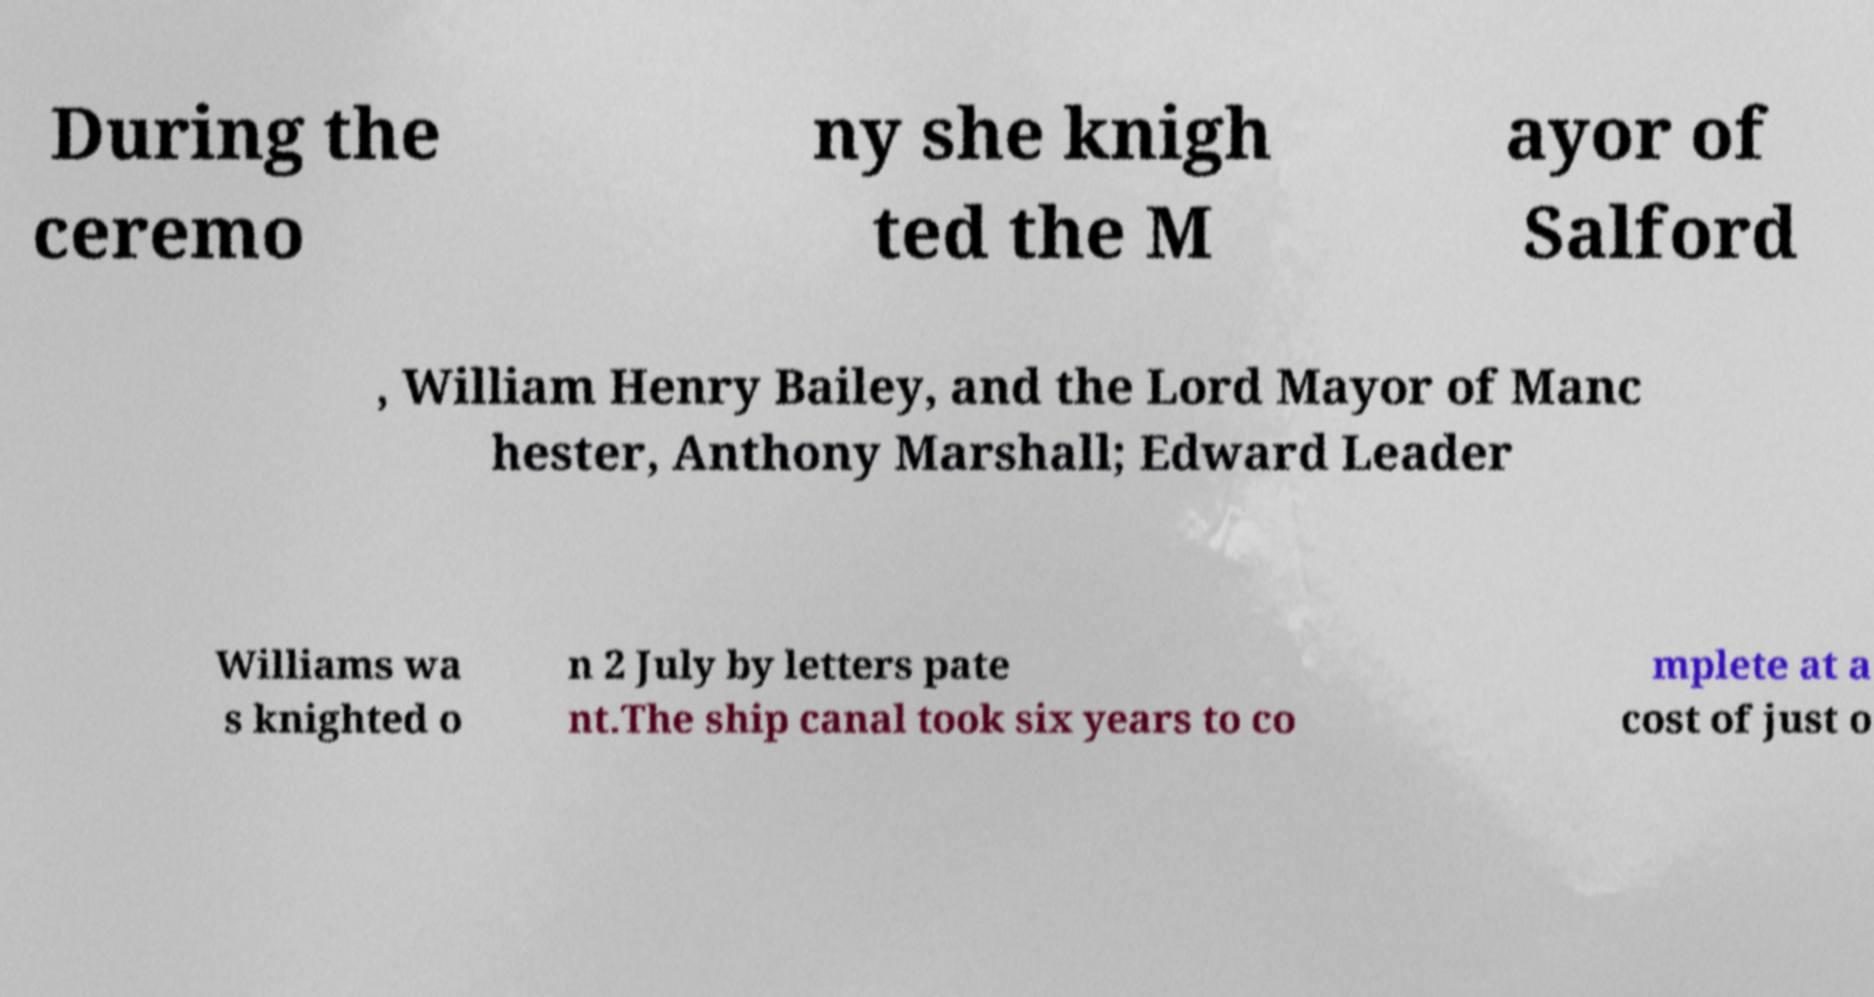What messages or text are displayed in this image? I need them in a readable, typed format. During the ceremo ny she knigh ted the M ayor of Salford , William Henry Bailey, and the Lord Mayor of Manc hester, Anthony Marshall; Edward Leader Williams wa s knighted o n 2 July by letters pate nt.The ship canal took six years to co mplete at a cost of just o 